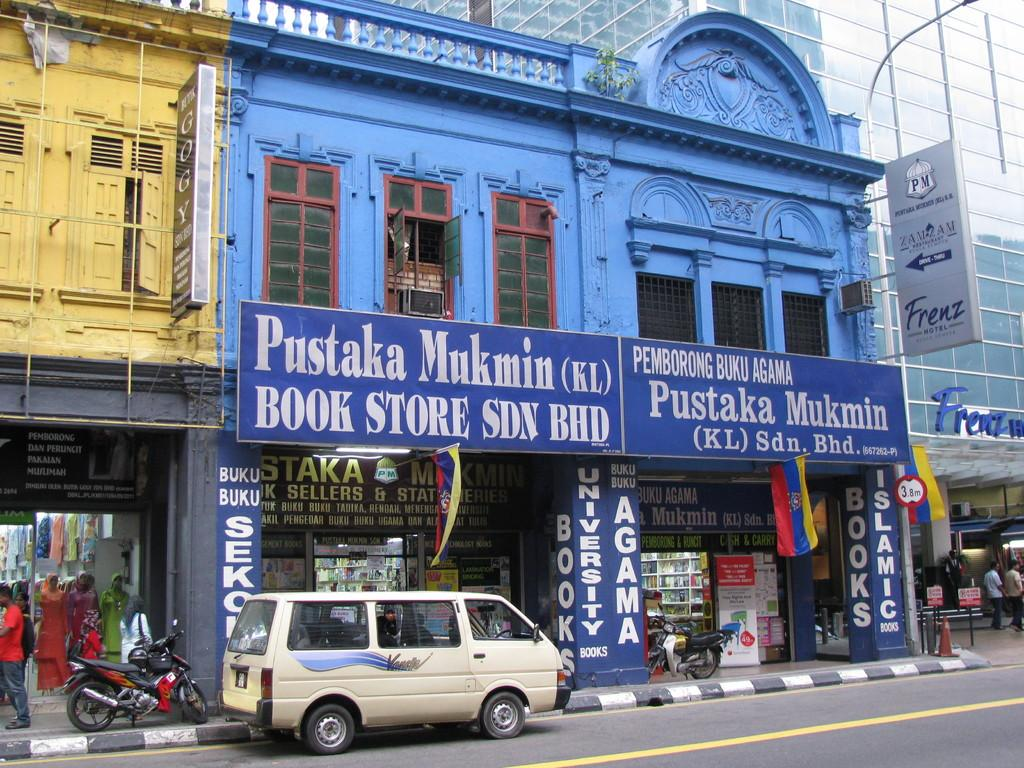<image>
Present a compact description of the photo's key features. A Book store on a busy street with a sign that says Pustaka Mukmin. 